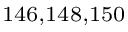Convert formula to latex. <formula><loc_0><loc_0><loc_500><loc_500>^ { 1 4 6 , 1 4 8 , 1 5 0 }</formula> 